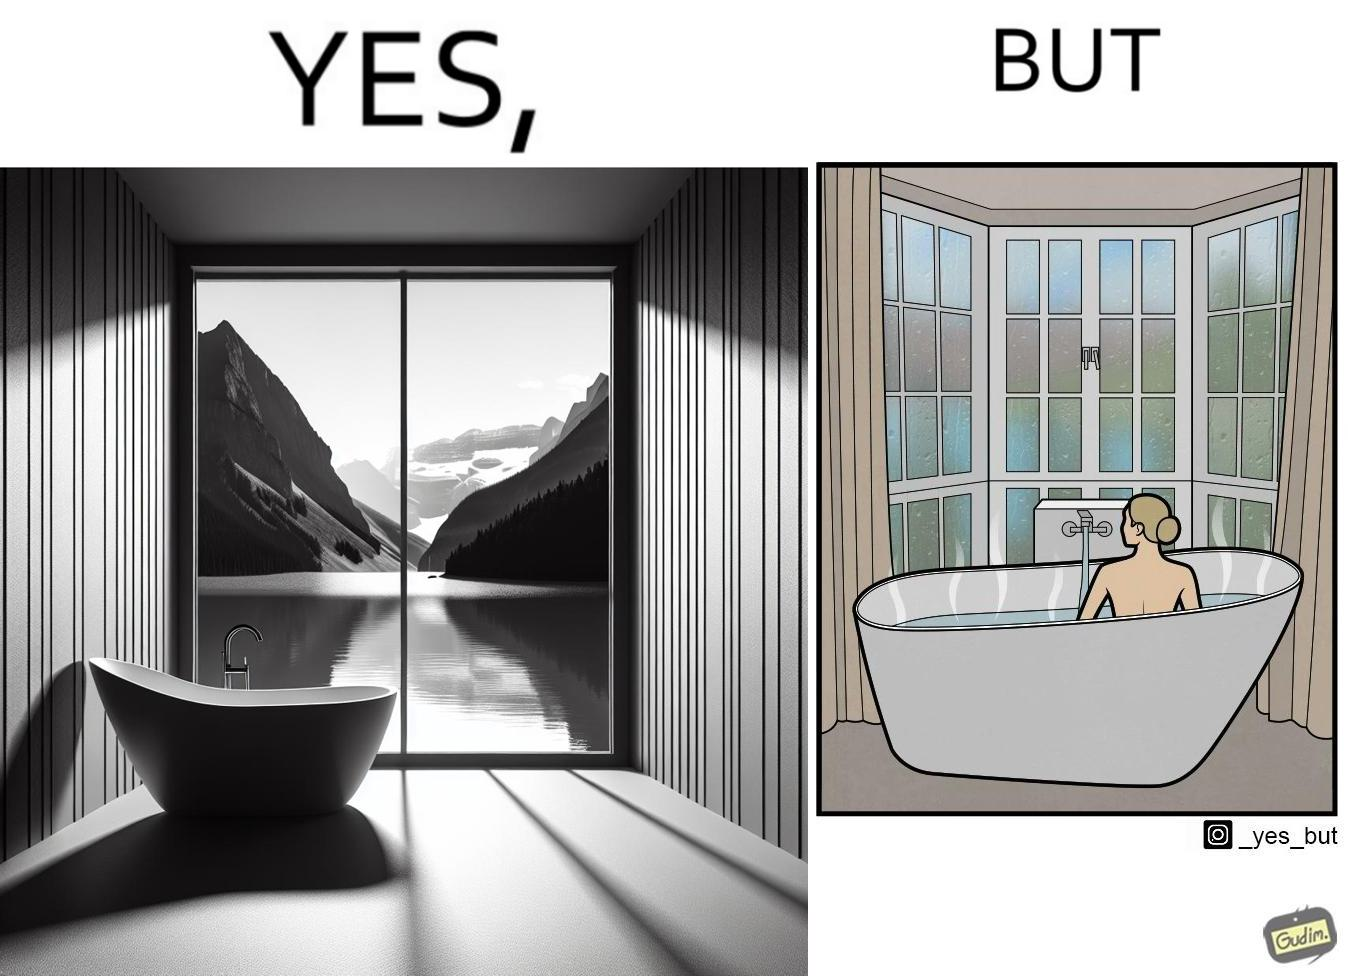Describe what you see in this image. The image is ironical, as a bathtub near a window having a very scenic view, becomes misty when someone is bathing, thus making the scenic view blurry. 